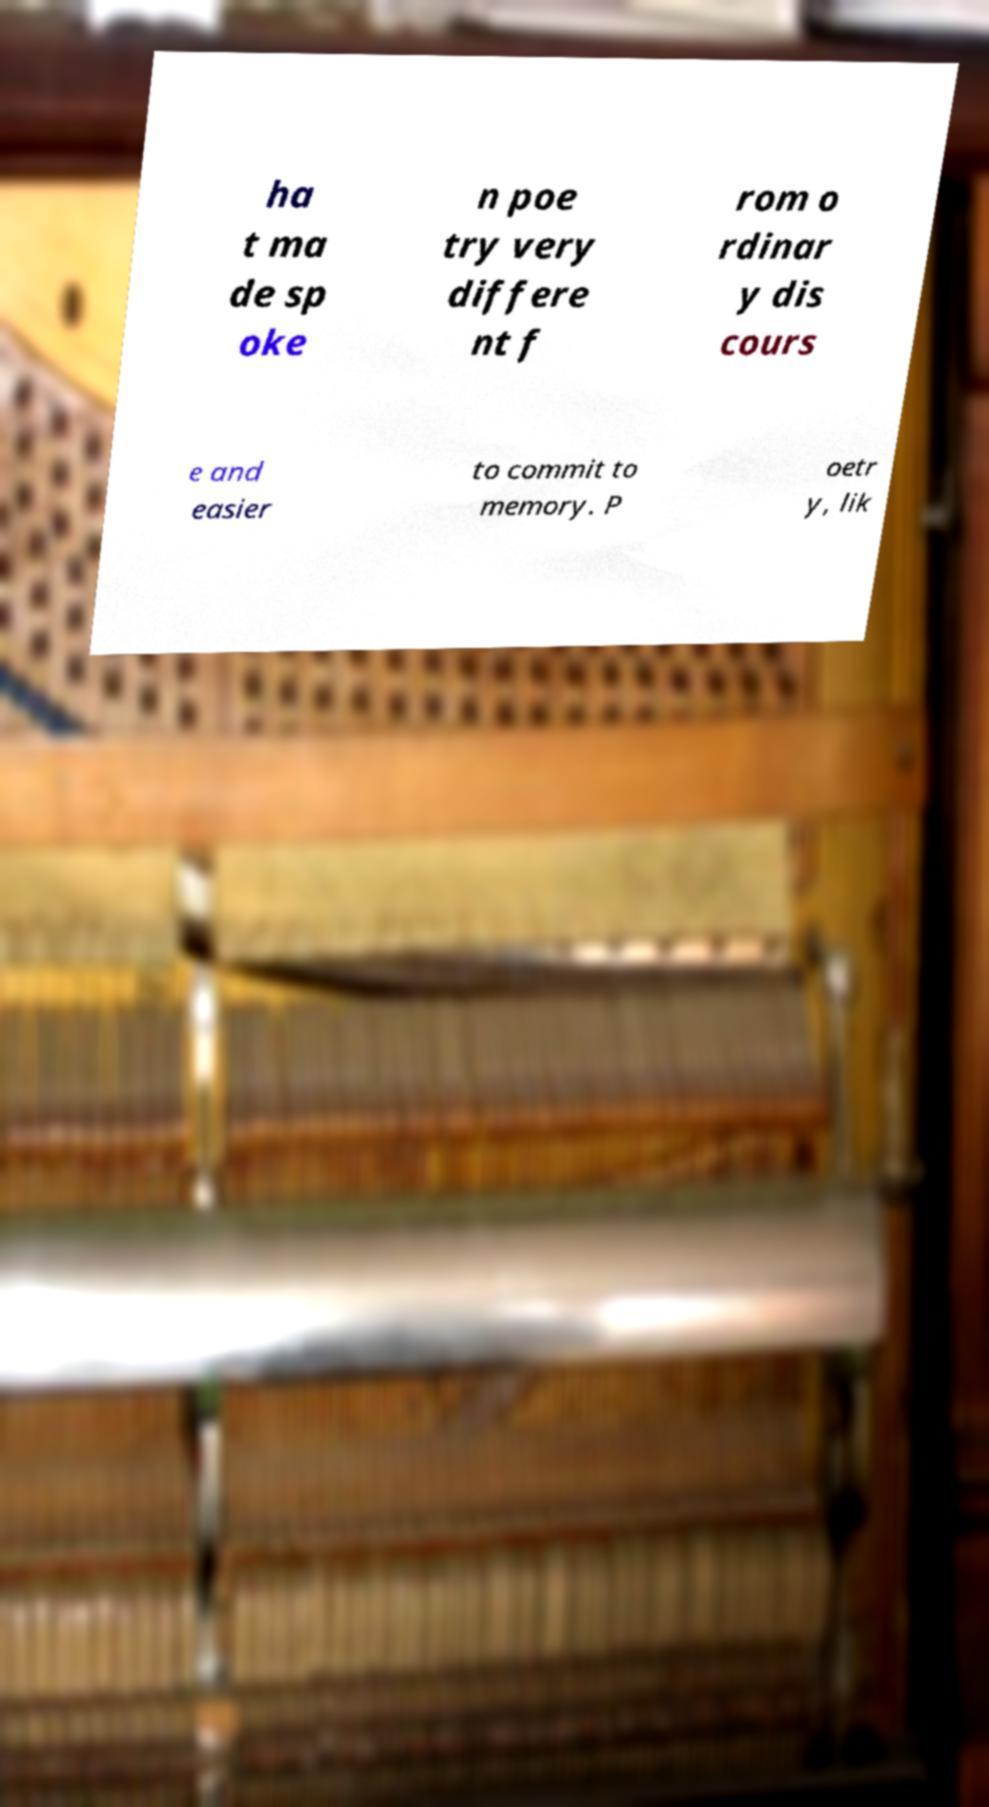I need the written content from this picture converted into text. Can you do that? ha t ma de sp oke n poe try very differe nt f rom o rdinar y dis cours e and easier to commit to memory. P oetr y, lik 